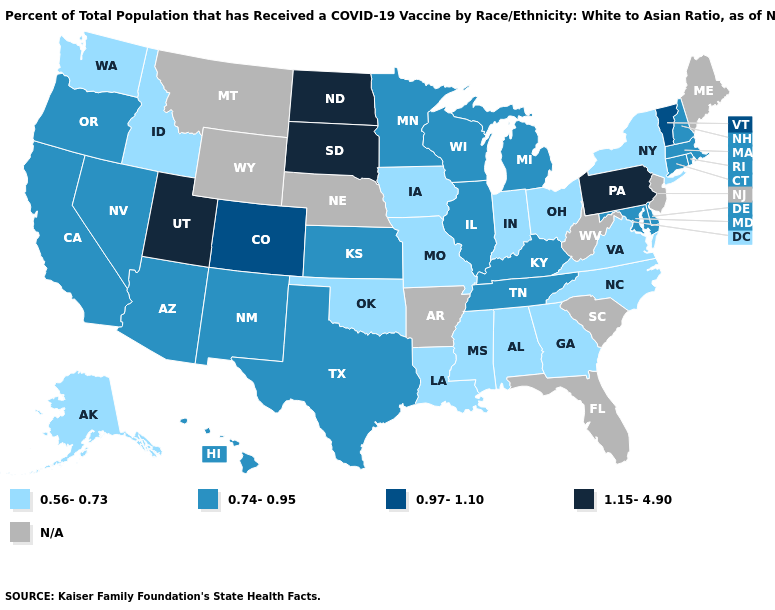What is the lowest value in states that border Rhode Island?
Answer briefly. 0.74-0.95. What is the lowest value in the West?
Write a very short answer. 0.56-0.73. Name the states that have a value in the range N/A?
Concise answer only. Arkansas, Florida, Maine, Montana, Nebraska, New Jersey, South Carolina, West Virginia, Wyoming. Name the states that have a value in the range 0.97-1.10?
Give a very brief answer. Colorado, Vermont. Name the states that have a value in the range N/A?
Short answer required. Arkansas, Florida, Maine, Montana, Nebraska, New Jersey, South Carolina, West Virginia, Wyoming. Among the states that border Nebraska , which have the lowest value?
Quick response, please. Iowa, Missouri. Does Texas have the highest value in the South?
Write a very short answer. Yes. Does Illinois have the lowest value in the USA?
Give a very brief answer. No. What is the highest value in states that border Delaware?
Concise answer only. 1.15-4.90. Among the states that border Georgia , does Alabama have the highest value?
Be succinct. No. What is the value of Virginia?
Give a very brief answer. 0.56-0.73. What is the value of Georgia?
Write a very short answer. 0.56-0.73. How many symbols are there in the legend?
Give a very brief answer. 5. What is the value of Arkansas?
Write a very short answer. N/A. 